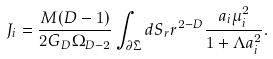<formula> <loc_0><loc_0><loc_500><loc_500>J _ { i } = \frac { M ( D - 1 ) } { 2 G _ { D } \Omega _ { D - 2 } } \int _ { \partial \bar { \Sigma } } d S _ { r } r ^ { 2 - D } \frac { a _ { i } \mu _ { i } ^ { 2 } } { 1 + \Lambda a _ { i } ^ { 2 } } .</formula> 